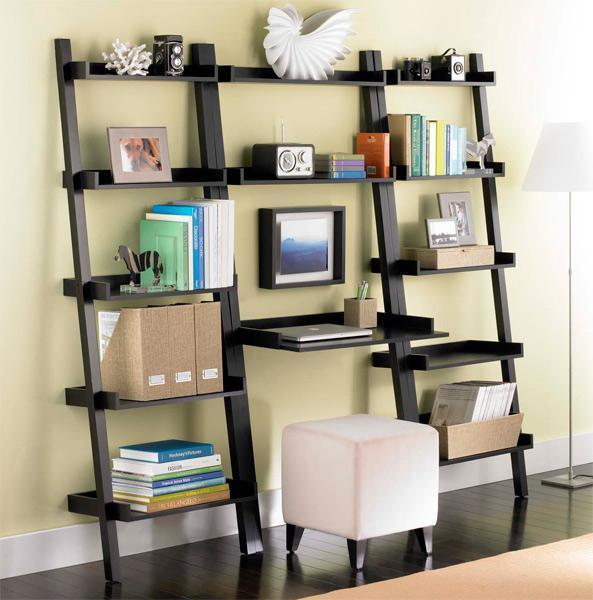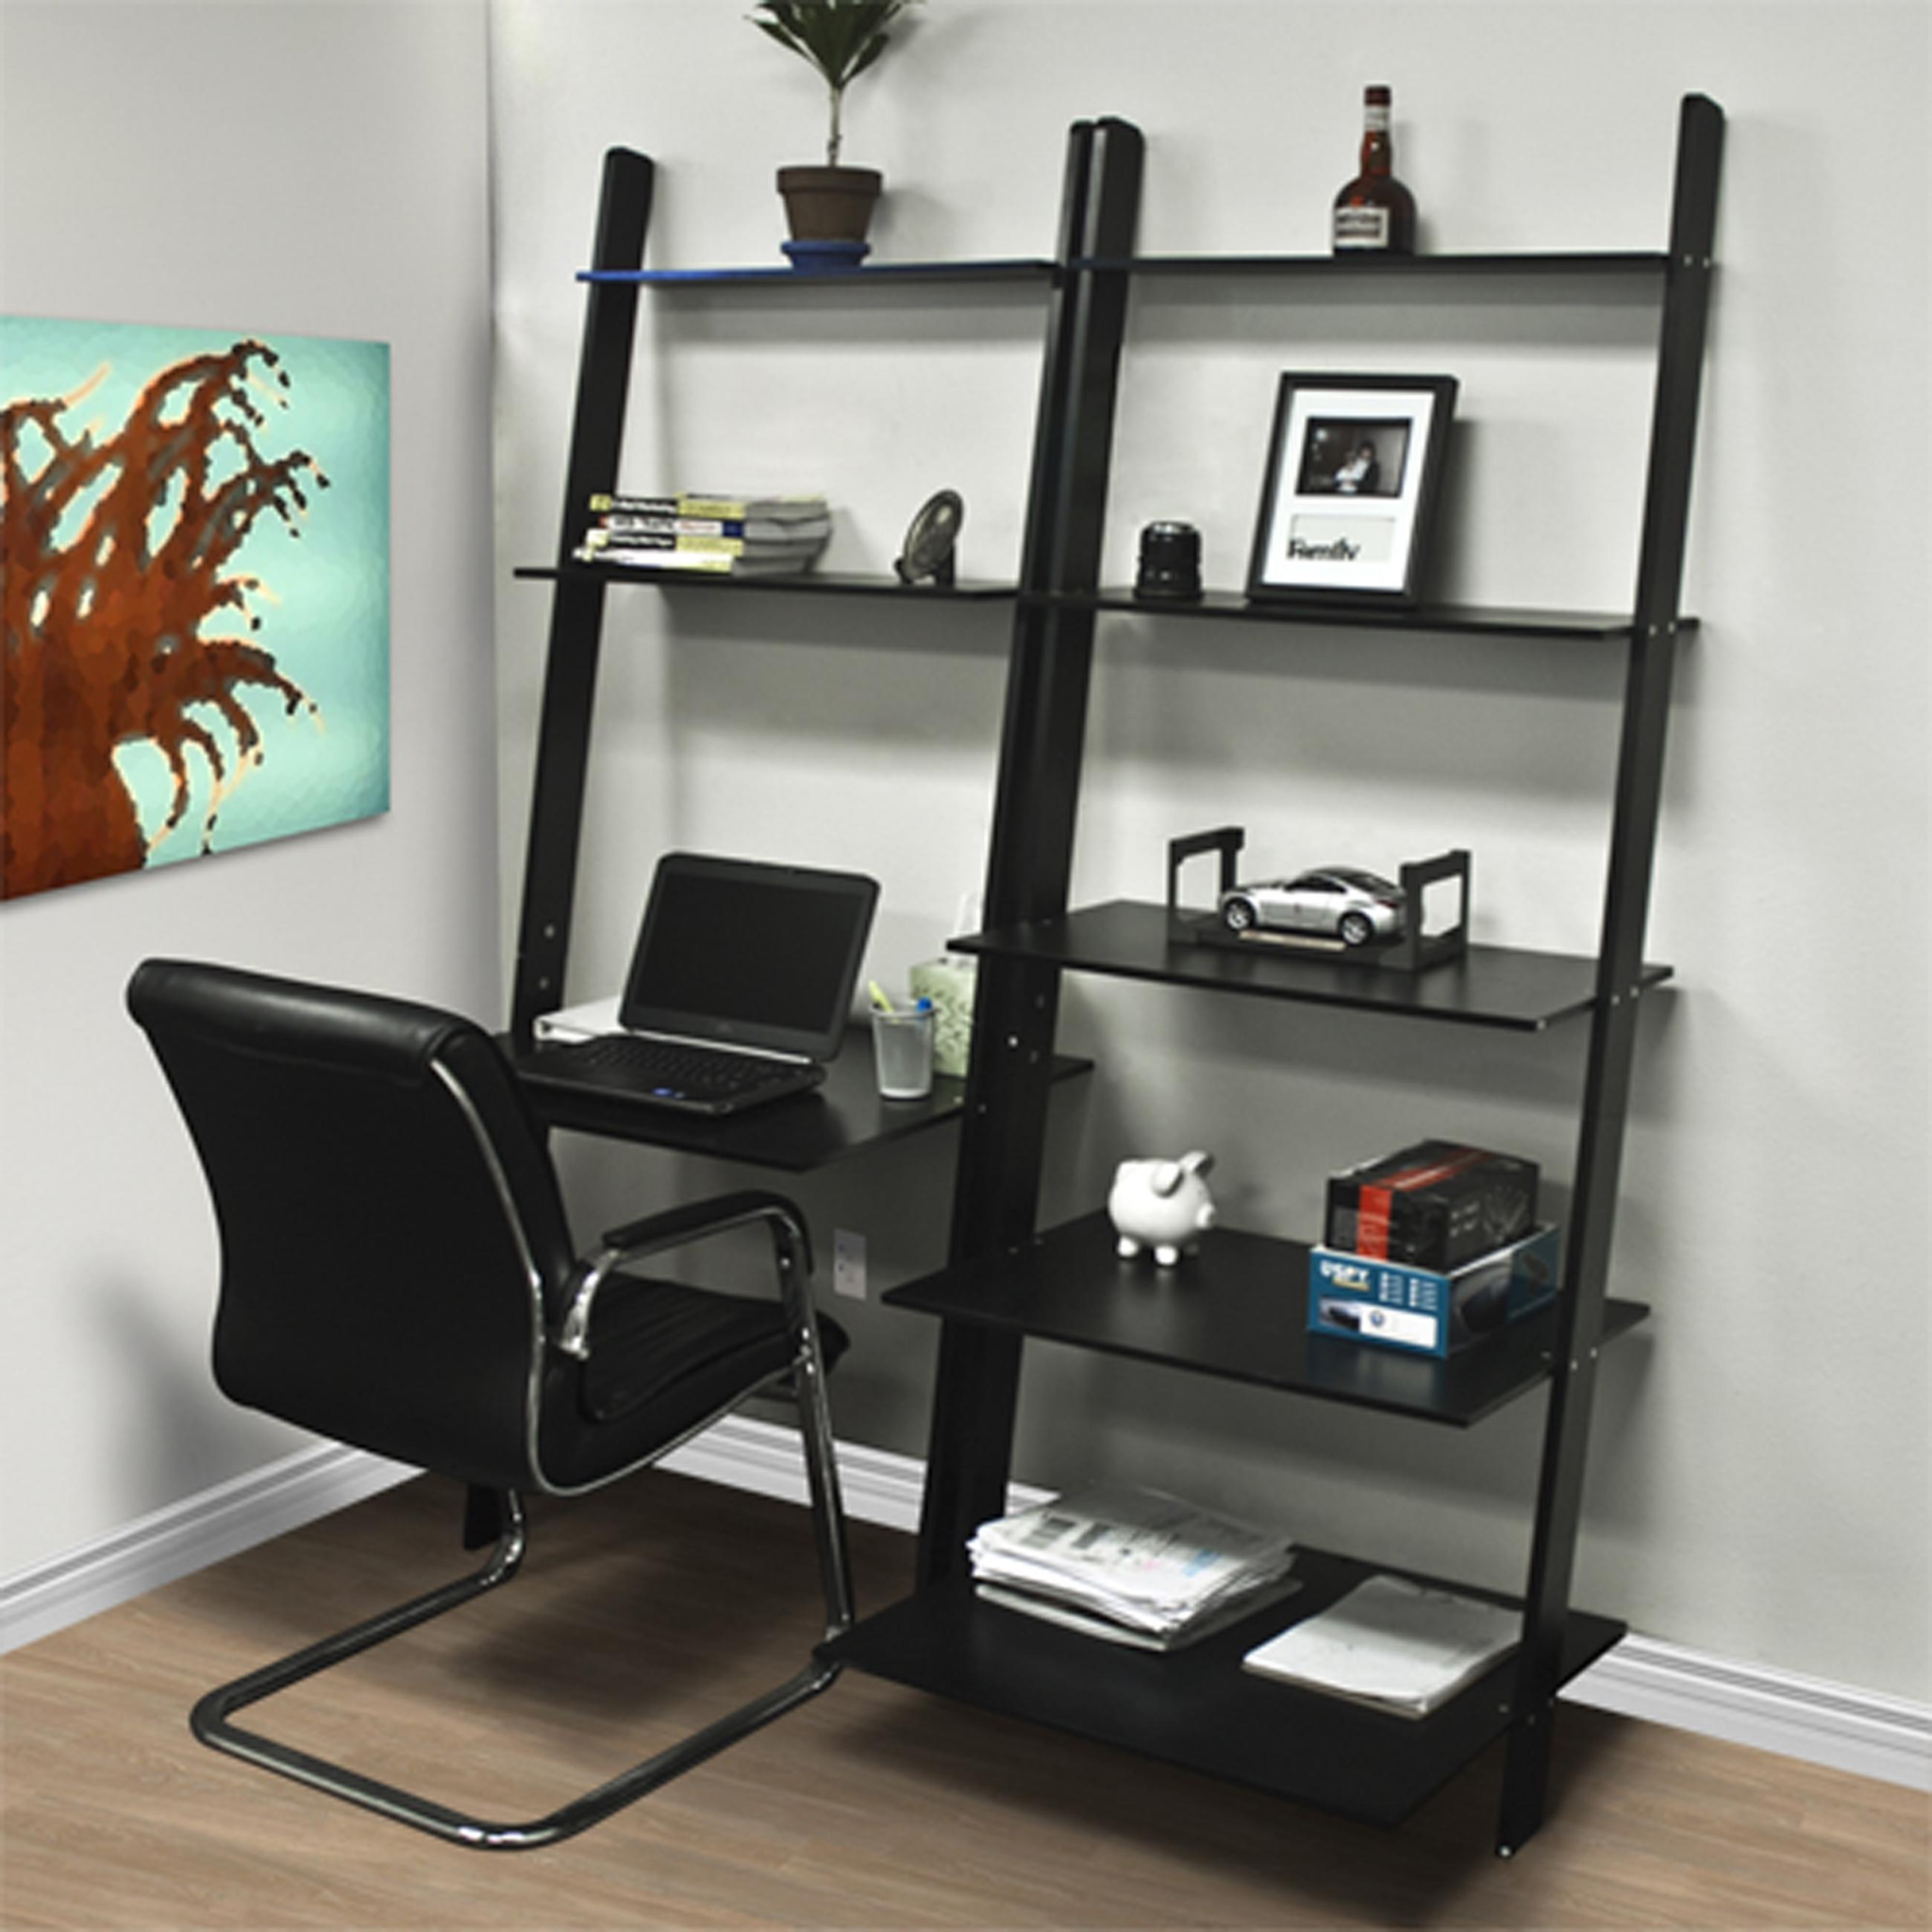The first image is the image on the left, the second image is the image on the right. Analyze the images presented: Is the assertion "there is a herringbone striped rug in front of a wall desk with a white chair with wooden legs" valid? Answer yes or no. No. The first image is the image on the left, the second image is the image on the right. Examine the images to the left and right. Is the description "A brown wooden book case sits up against the wall displaying many different items including a laptop." accurate? Answer yes or no. No. 